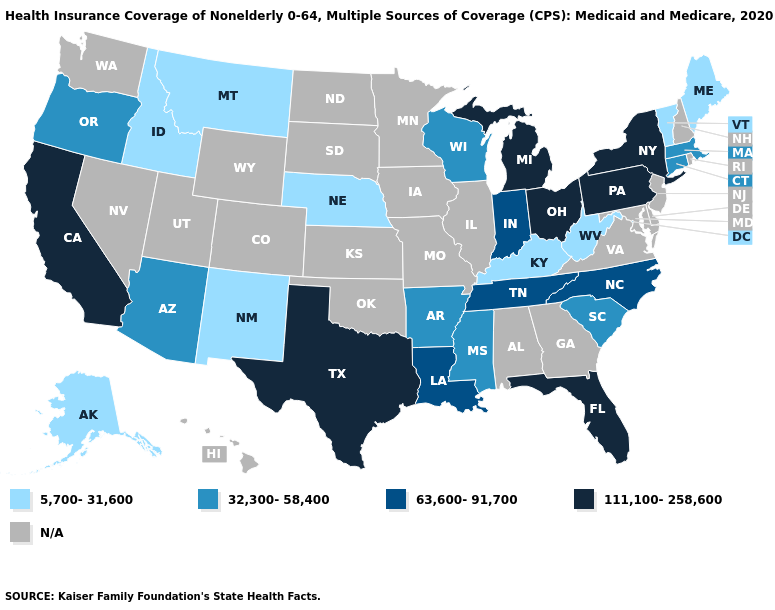What is the value of Delaware?
Give a very brief answer. N/A. Does the map have missing data?
Short answer required. Yes. What is the value of Arizona?
Concise answer only. 32,300-58,400. What is the value of Montana?
Concise answer only. 5,700-31,600. Is the legend a continuous bar?
Be succinct. No. Which states have the highest value in the USA?
Write a very short answer. California, Florida, Michigan, New York, Ohio, Pennsylvania, Texas. Among the states that border Iowa , which have the highest value?
Be succinct. Wisconsin. Which states have the lowest value in the USA?
Concise answer only. Alaska, Idaho, Kentucky, Maine, Montana, Nebraska, New Mexico, Vermont, West Virginia. What is the value of Pennsylvania?
Concise answer only. 111,100-258,600. What is the value of Alaska?
Write a very short answer. 5,700-31,600. What is the value of North Dakota?
Write a very short answer. N/A. 